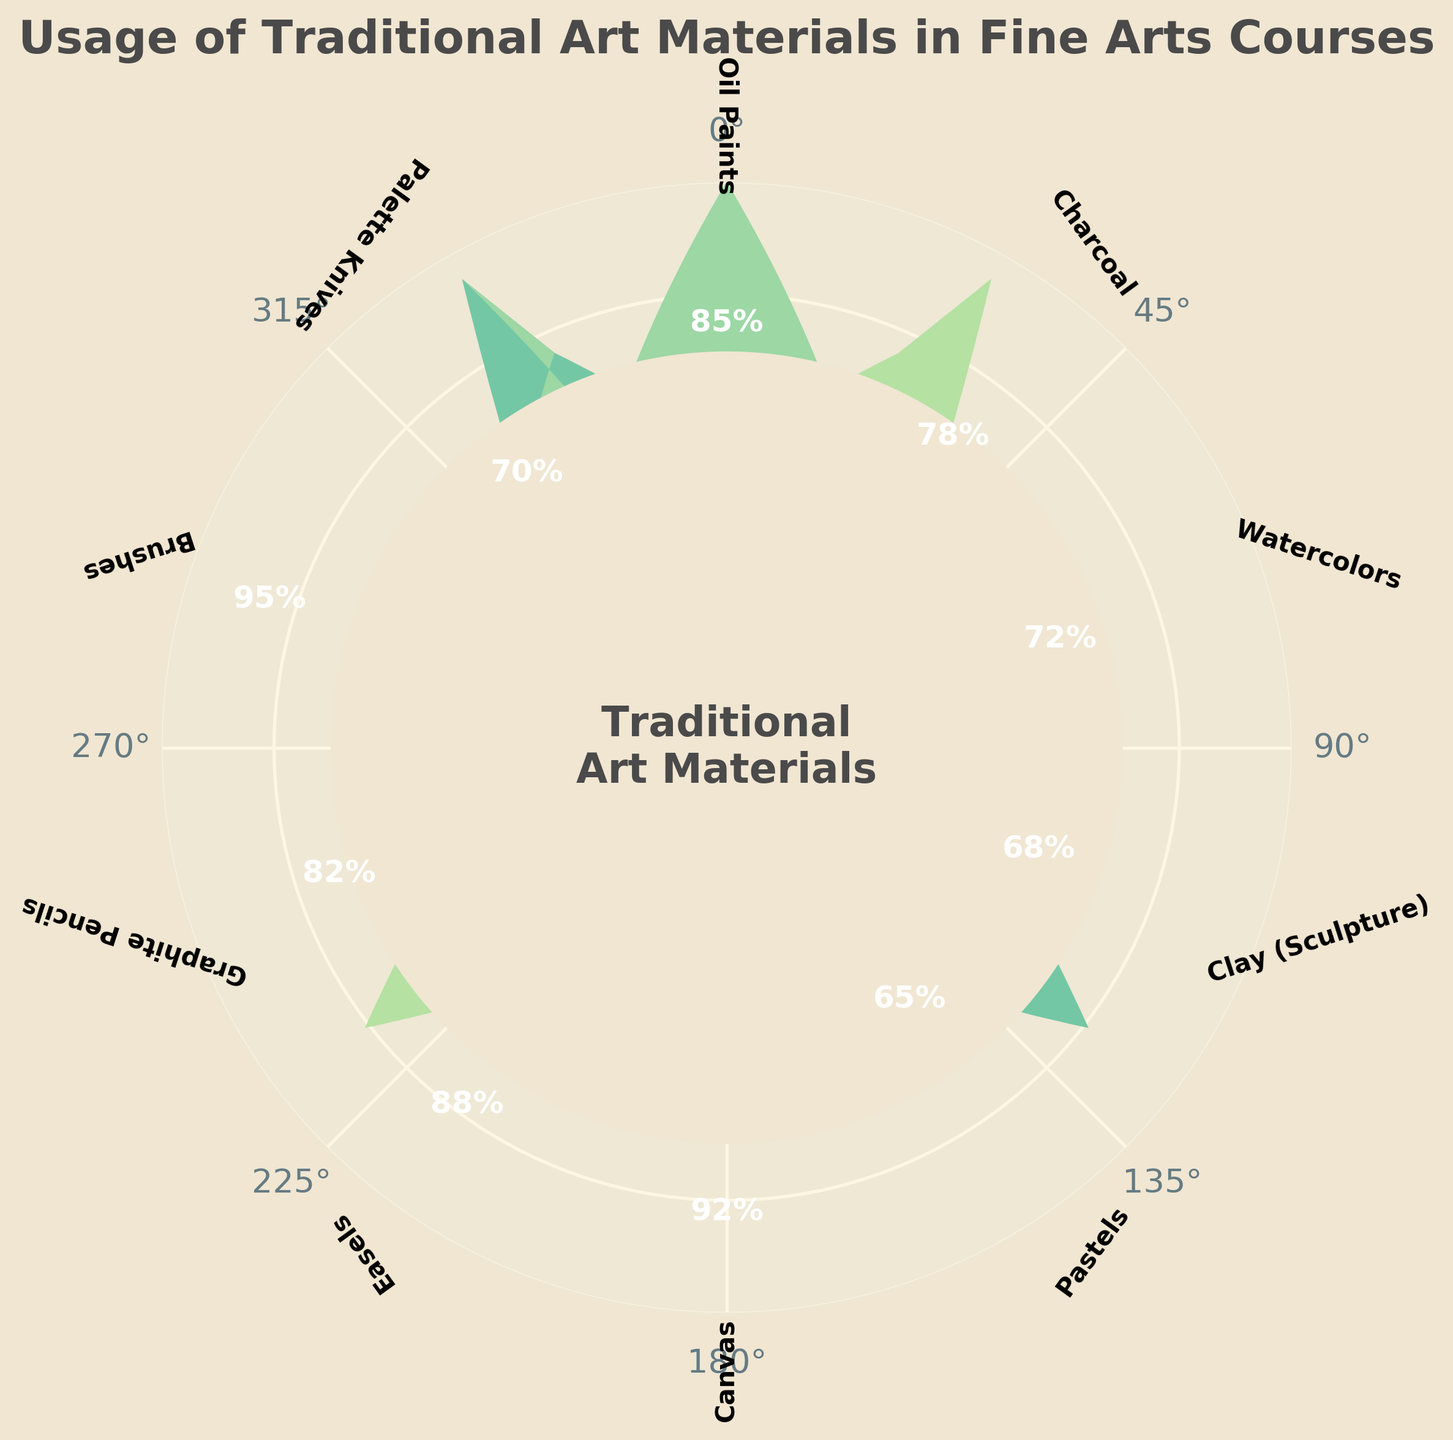how many different traditional art materials are shown in the figure? The figure displays different traditional art materials represented by distinct wedges. Counting these wedges will give the total number of materials shown.
Answer: 10 What is the title of the figure? The title is usually located at the top of the figure and provides a summary of what the figure represents.
Answer: Usage of Traditional Art Materials in Fine Arts Courses Which material has the highest percentage of use in the figure? Observing the percentages annotated on the figure, the highest percentage value will indicate the material with the most use.
Answer: Brushes What is the percentage difference between the usage of graphite pencils and charcoal? Locate the percentage associated with each material, then subtract the smaller percentage (charcoal's 78%) from the larger one (graphite pencil's 82%).
Answer: 4% Which materials have a usage percentage above 90%? Identify the materials whose percentage values are above 90% by looking at the annotations around the circle.
Answer: Canvas, Brushes Comparing oil paints and watercolors, which one is used more frequently and by what percentage? Identify the percentages for both oil paints and watercolors (85% and 72% respectively). Subtract the smaller percentage from the larger to find the difference.
Answer: Oil Paints, 13% Are there any materials with a usage rate lower than 70%? Review all the percentage values and identify any materials with a value below 70%.
Answer: Clay (Sculpture), Pastels, Palette Knives If you were to average the usage percentages of oil paints, charcoal, and watercolors, what would the average be? Add the percentages of oil paints (85%), charcoal (78%), and watercolors (72%), then divide by 3 to get the average.
Answer: 78.33% Which material has a percentage closest to the median value of all listed materials' percentages? First, arrange all the percentages in order and find the median value (the middle value in a sorted list of numbers). The material with the closest percentage to this median is the answer.
Answer: Graphite Pencils (median is 80%) Does any material have exactly 70% usage, and if so, which one is it? Locate the material that has an annotated percentage of exactly 70% within the figure.
Answer: Palette Knives 